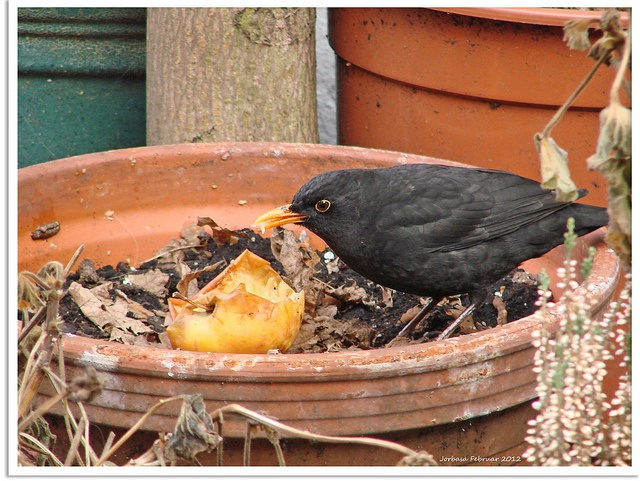Describe the objects in this image and their specific colors. I can see potted plant in white, gray, and tan tones, potted plant in white, brown, red, and maroon tones, bird in white, gray, and black tones, and apple in white, orange, tan, and gold tones in this image. 